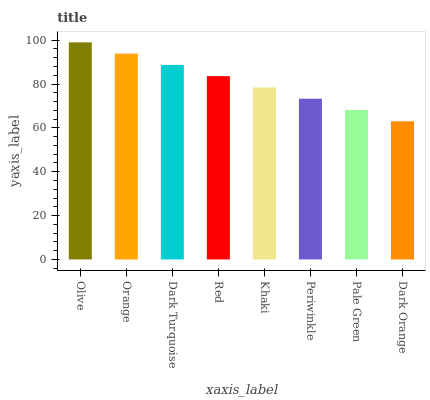Is Dark Orange the minimum?
Answer yes or no. Yes. Is Olive the maximum?
Answer yes or no. Yes. Is Orange the minimum?
Answer yes or no. No. Is Orange the maximum?
Answer yes or no. No. Is Olive greater than Orange?
Answer yes or no. Yes. Is Orange less than Olive?
Answer yes or no. Yes. Is Orange greater than Olive?
Answer yes or no. No. Is Olive less than Orange?
Answer yes or no. No. Is Red the high median?
Answer yes or no. Yes. Is Khaki the low median?
Answer yes or no. Yes. Is Periwinkle the high median?
Answer yes or no. No. Is Red the low median?
Answer yes or no. No. 